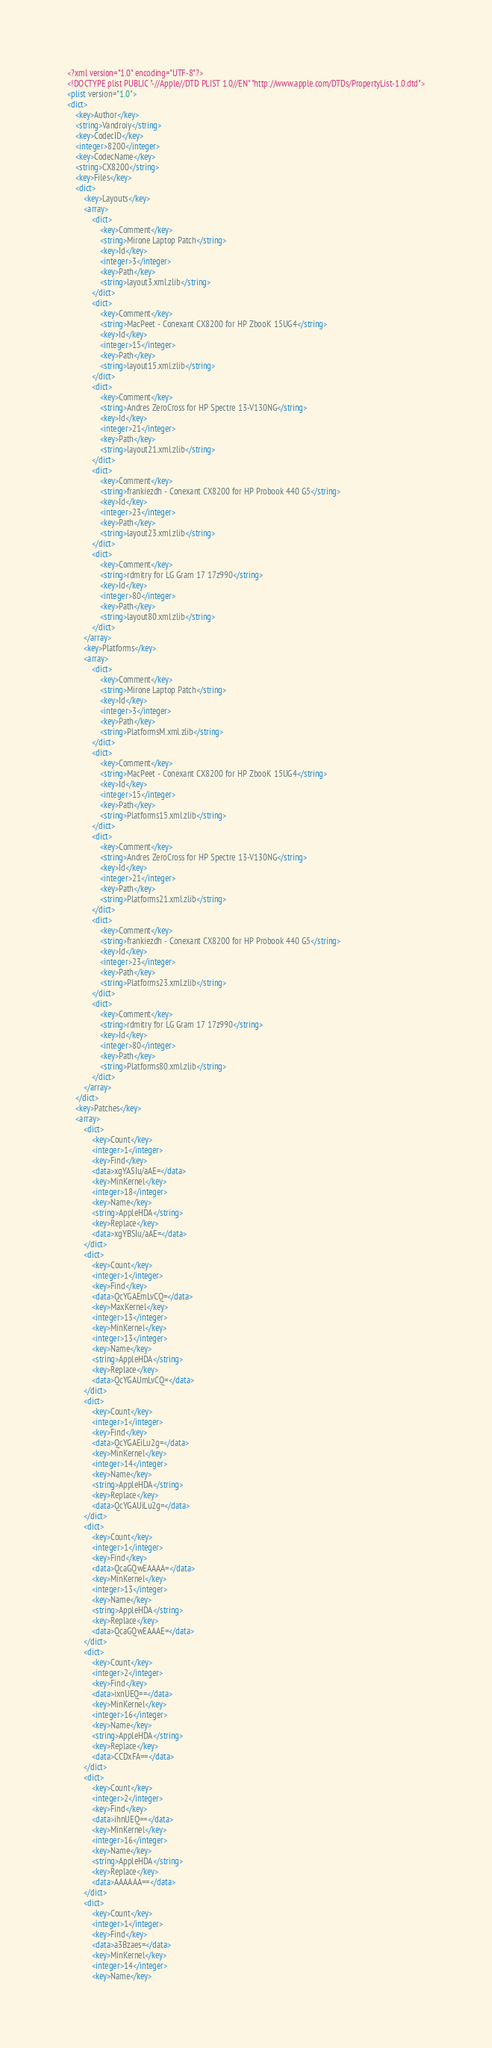<code> <loc_0><loc_0><loc_500><loc_500><_XML_><?xml version="1.0" encoding="UTF-8"?>
<!DOCTYPE plist PUBLIC "-//Apple//DTD PLIST 1.0//EN" "http://www.apple.com/DTDs/PropertyList-1.0.dtd">
<plist version="1.0">
<dict>
	<key>Author</key>
	<string>Vandroiy</string>
	<key>CodecID</key>
	<integer>8200</integer>
	<key>CodecName</key>
	<string>CX8200</string>
	<key>Files</key>
	<dict>
		<key>Layouts</key>
		<array>
			<dict>
				<key>Comment</key>
				<string>Mirone Laptop Patch</string>
				<key>Id</key>
				<integer>3</integer>
				<key>Path</key>
				<string>layout3.xml.zlib</string>
			</dict>
			<dict>
				<key>Comment</key>
				<string>MacPeet - Conexant CX8200 for HP ZbooK 15UG4</string>
				<key>Id</key>
				<integer>15</integer>
				<key>Path</key>
				<string>layout15.xml.zlib</string>
			</dict>
			<dict>
				<key>Comment</key>
				<string>Andres ZeroCross for HP Spectre 13-V130NG</string>
				<key>Id</key>
				<integer>21</integer>
				<key>Path</key>
				<string>layout21.xml.zlib</string>
			</dict>
			<dict>
				<key>Comment</key>
				<string>frankiezdh - Conexant CX8200 for HP Probook 440 G5</string>
				<key>Id</key>
				<integer>23</integer>
				<key>Path</key>
				<string>layout23.xml.zlib</string>
			</dict>
			<dict>
				<key>Comment</key>
				<string>rdmitry for LG Gram 17 17z990</string>
				<key>Id</key>
				<integer>80</integer>
				<key>Path</key>
				<string>layout80.xml.zlib</string>
			</dict>
		</array>
		<key>Platforms</key>
		<array>
			<dict>
				<key>Comment</key>
				<string>Mirone Laptop Patch</string>
				<key>Id</key>
				<integer>3</integer>
				<key>Path</key>
				<string>PlatformsM.xml.zlib</string>
			</dict>
			<dict>
				<key>Comment</key>
				<string>MacPeet - Conexant CX8200 for HP ZbooK 15UG4</string>
				<key>Id</key>
				<integer>15</integer>
				<key>Path</key>
				<string>Platforms15.xml.zlib</string>
			</dict>
			<dict>
				<key>Comment</key>
				<string>Andres ZeroCross for HP Spectre 13-V130NG</string>
				<key>Id</key>
				<integer>21</integer>
				<key>Path</key>
				<string>Platforms21.xml.zlib</string>
			</dict>
			<dict>
				<key>Comment</key>
				<string>frankiezdh - Conexant CX8200 for HP Probook 440 G5</string>
				<key>Id</key>
				<integer>23</integer>
				<key>Path</key>
				<string>Platforms23.xml.zlib</string>
			</dict>
			<dict>
				<key>Comment</key>
				<string>rdmitry for LG Gram 17 17z990</string>
				<key>Id</key>
				<integer>80</integer>
				<key>Path</key>
				<string>Platforms80.xml.zlib</string>
			</dict>
		</array>
	</dict>
	<key>Patches</key>
	<array>
		<dict>
			<key>Count</key>
			<integer>1</integer>
			<key>Find</key>
			<data>xgYASIu/aAE=</data>
			<key>MinKernel</key>
			<integer>18</integer>
			<key>Name</key>
			<string>AppleHDA</string>
			<key>Replace</key>
			<data>xgYBSIu/aAE=</data>
		</dict>
		<dict>
			<key>Count</key>
			<integer>1</integer>
			<key>Find</key>
			<data>QcYGAEmLvCQ=</data>
			<key>MaxKernel</key>
			<integer>13</integer>
			<key>MinKernel</key>
			<integer>13</integer>
			<key>Name</key>
			<string>AppleHDA</string>
			<key>Replace</key>
			<data>QcYGAUmLvCQ=</data>
		</dict>
		<dict>
			<key>Count</key>
			<integer>1</integer>
			<key>Find</key>
			<data>QcYGAEiLu2g=</data>
			<key>MinKernel</key>
			<integer>14</integer>
			<key>Name</key>
			<string>AppleHDA</string>
			<key>Replace</key>
			<data>QcYGAUiLu2g=</data>
		</dict>
		<dict>
			<key>Count</key>
			<integer>1</integer>
			<key>Find</key>
			<data>QcaGQwEAAAA=</data>
			<key>MinKernel</key>
			<integer>13</integer>
			<key>Name</key>
			<string>AppleHDA</string>
			<key>Replace</key>
			<data>QcaGQwEAAAE=</data>
		</dict>
		<dict>
			<key>Count</key>
			<integer>2</integer>
			<key>Find</key>
			<data>ixnUEQ==</data>
			<key>MinKernel</key>
			<integer>16</integer>
			<key>Name</key>
			<string>AppleHDA</string>
			<key>Replace</key>
			<data>CCDxFA==</data>
		</dict>
		<dict>
			<key>Count</key>
			<integer>2</integer>
			<key>Find</key>
			<data>ihnUEQ==</data>
			<key>MinKernel</key>
			<integer>16</integer>
			<key>Name</key>
			<string>AppleHDA</string>
			<key>Replace</key>
			<data>AAAAAA==</data>
		</dict>
		<dict>
			<key>Count</key>
			<integer>1</integer>
			<key>Find</key>
			<data>a3Bzaes=</data>
			<key>MinKernel</key>
			<integer>14</integer>
			<key>Name</key></code> 